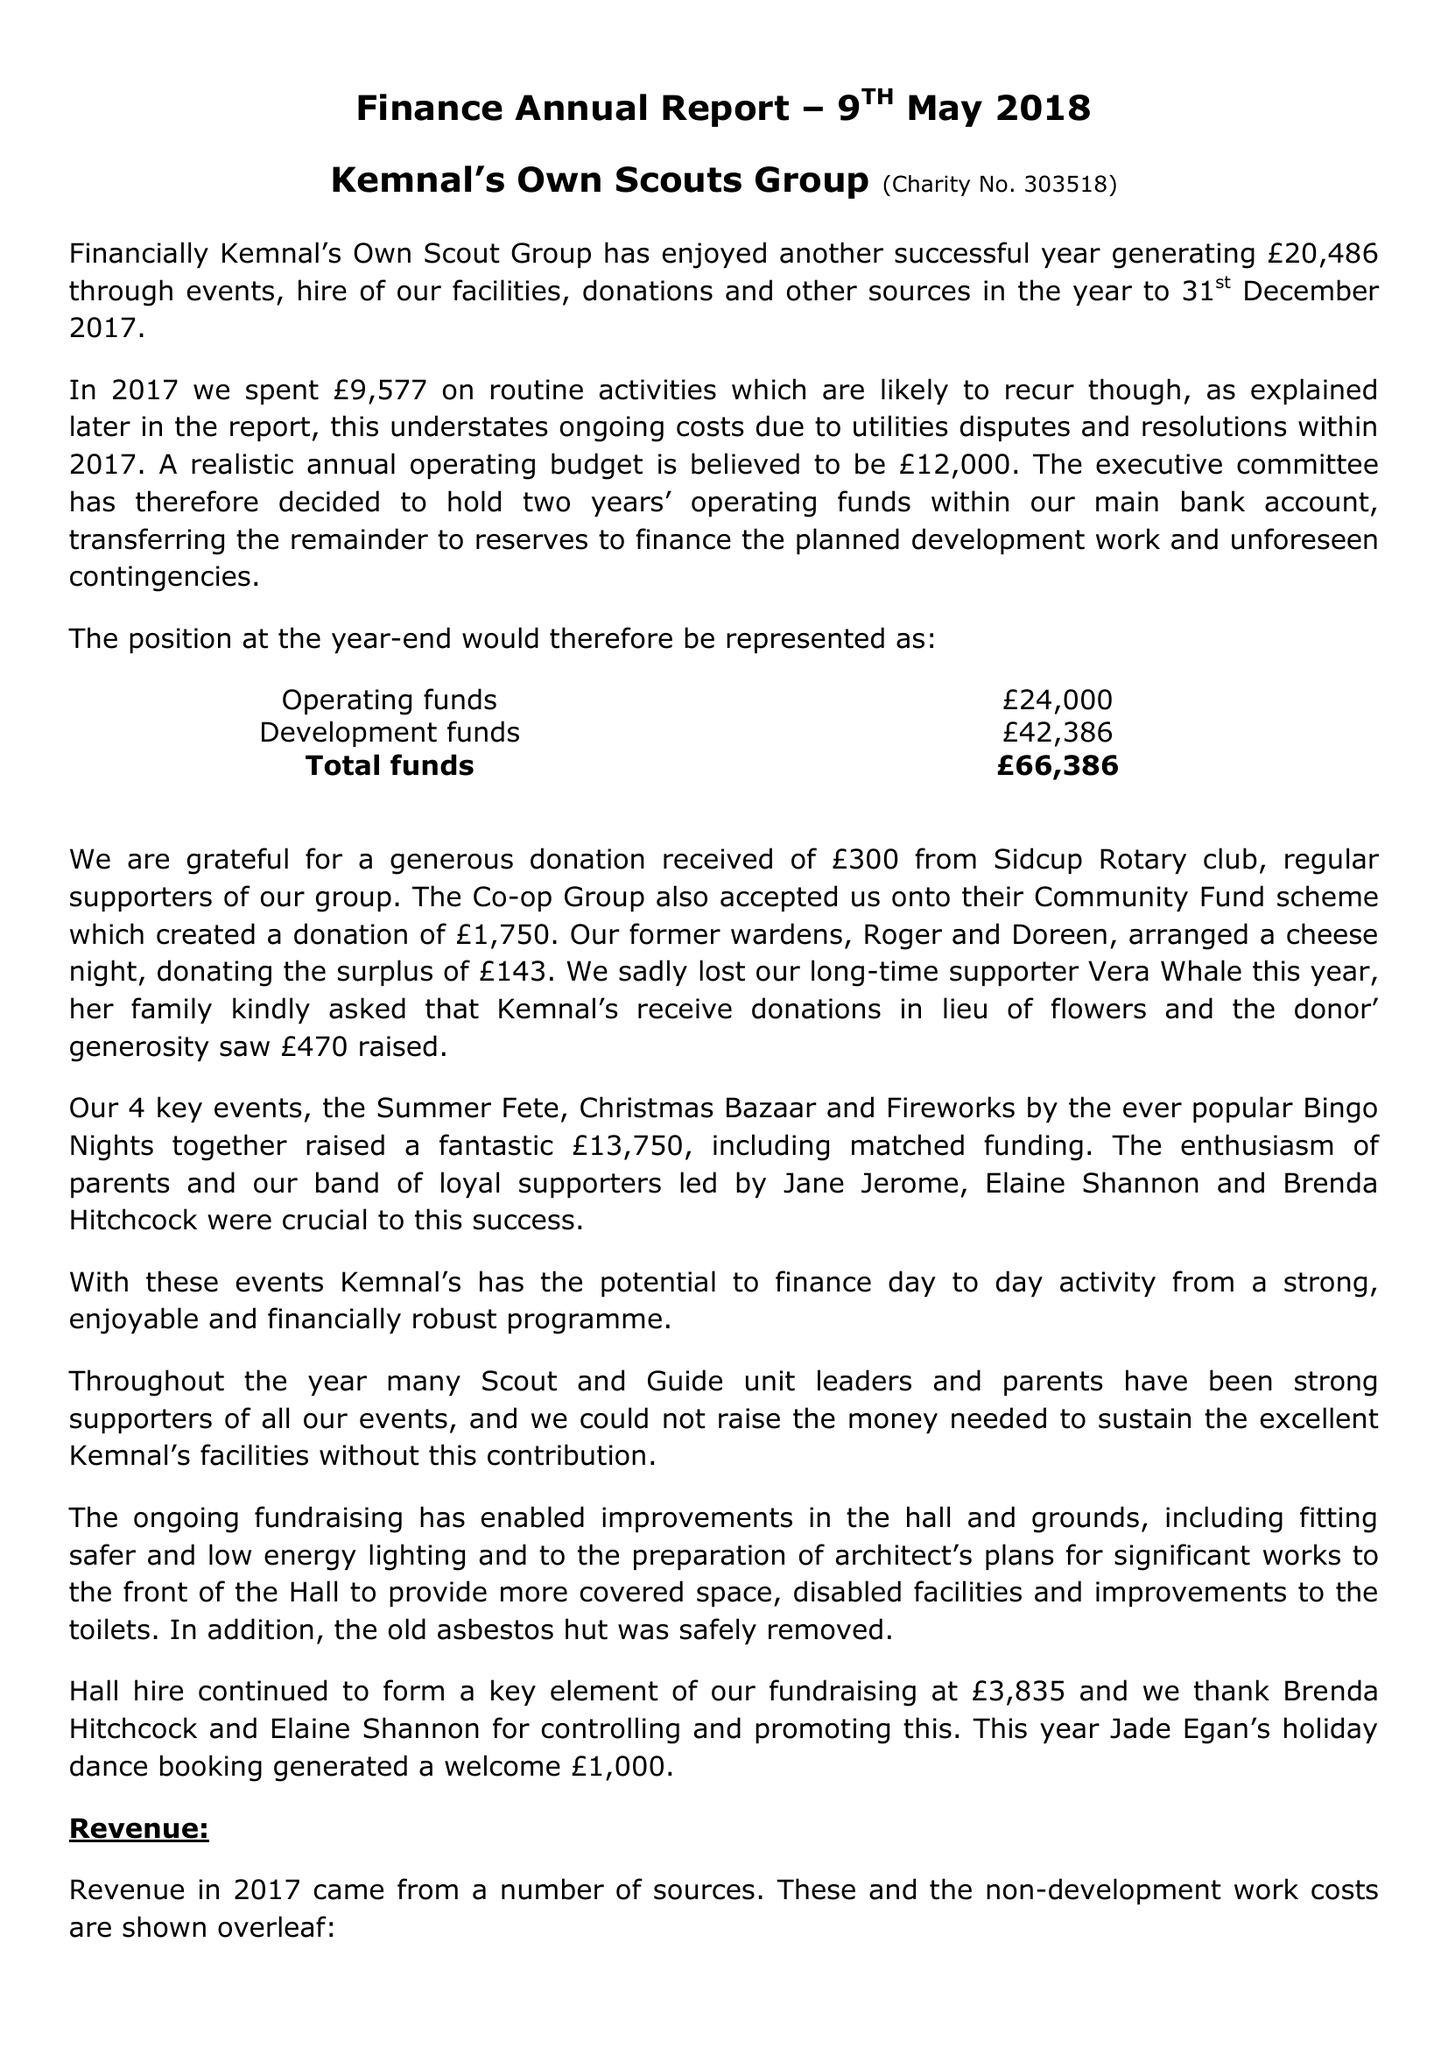What is the value for the charity_name?
Answer the question using a single word or phrase. Kemnal's Own Scout Group 